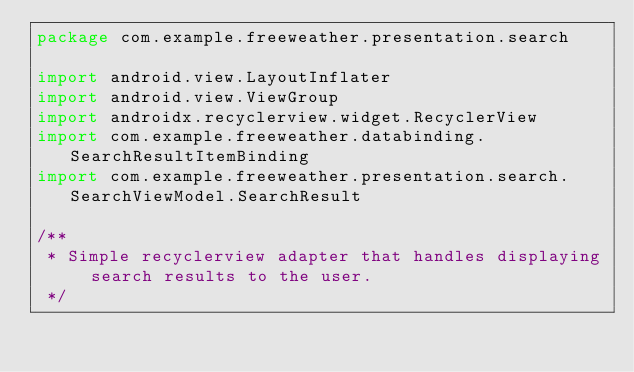Convert code to text. <code><loc_0><loc_0><loc_500><loc_500><_Kotlin_>package com.example.freeweather.presentation.search

import android.view.LayoutInflater
import android.view.ViewGroup
import androidx.recyclerview.widget.RecyclerView
import com.example.freeweather.databinding.SearchResultItemBinding
import com.example.freeweather.presentation.search.SearchViewModel.SearchResult

/**
 * Simple recyclerview adapter that handles displaying search results to the user.
 */</code> 